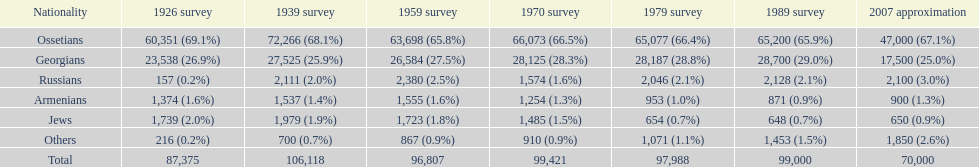How many ethnicities were below 1,000 people in 2007? 2. 